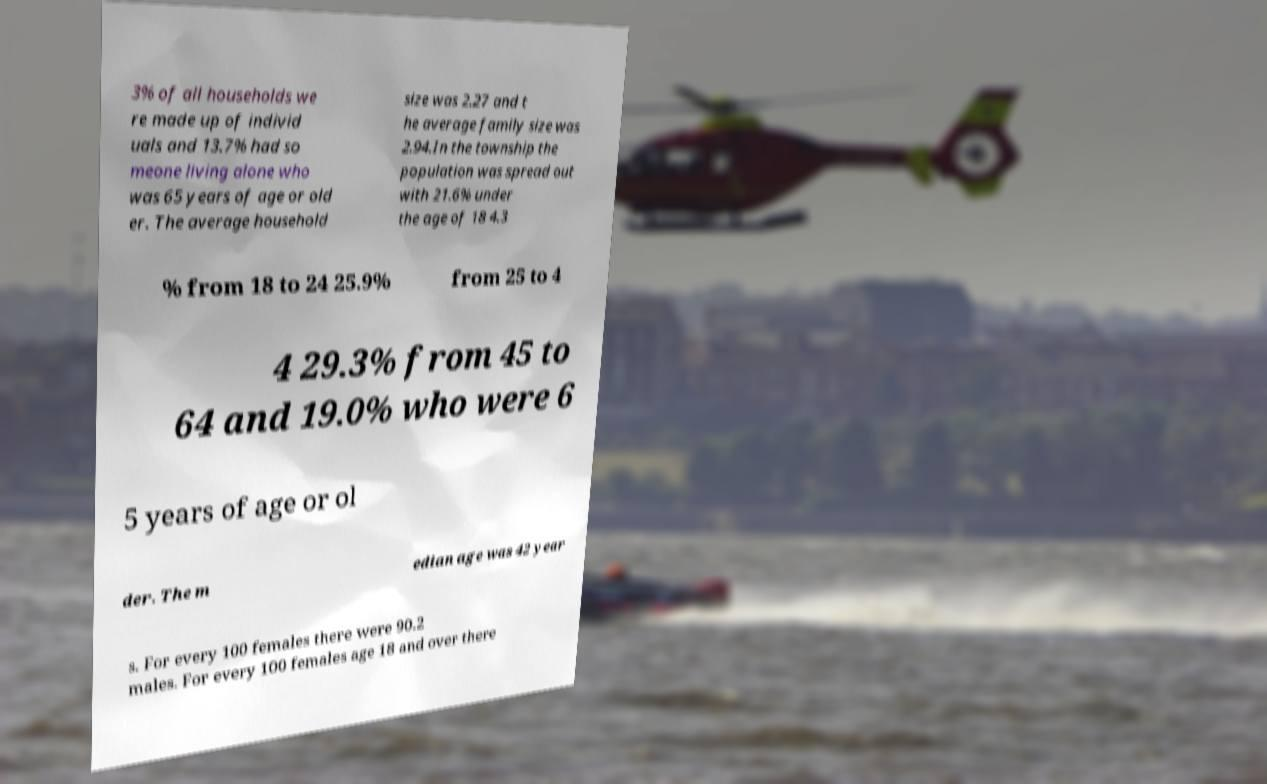I need the written content from this picture converted into text. Can you do that? 3% of all households we re made up of individ uals and 13.7% had so meone living alone who was 65 years of age or old er. The average household size was 2.27 and t he average family size was 2.94.In the township the population was spread out with 21.6% under the age of 18 4.3 % from 18 to 24 25.9% from 25 to 4 4 29.3% from 45 to 64 and 19.0% who were 6 5 years of age or ol der. The m edian age was 42 year s. For every 100 females there were 90.2 males. For every 100 females age 18 and over there 